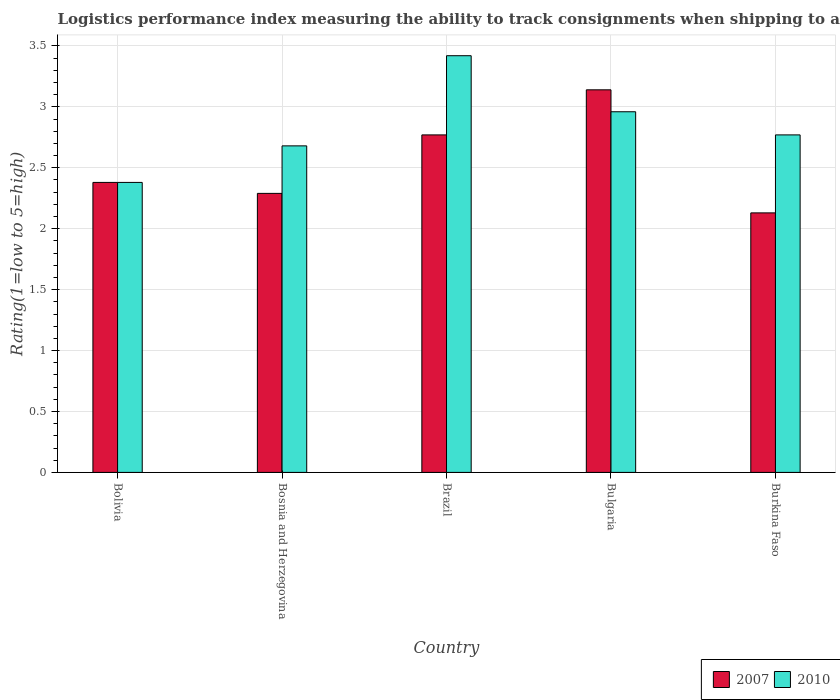How many groups of bars are there?
Your answer should be compact. 5. How many bars are there on the 4th tick from the left?
Your answer should be compact. 2. What is the label of the 4th group of bars from the left?
Provide a succinct answer. Bulgaria. What is the Logistic performance index in 2010 in Bosnia and Herzegovina?
Make the answer very short. 2.68. Across all countries, what is the maximum Logistic performance index in 2007?
Provide a succinct answer. 3.14. Across all countries, what is the minimum Logistic performance index in 2010?
Give a very brief answer. 2.38. In which country was the Logistic performance index in 2007 minimum?
Your response must be concise. Burkina Faso. What is the total Logistic performance index in 2010 in the graph?
Your answer should be very brief. 14.21. What is the difference between the Logistic performance index in 2007 in Bosnia and Herzegovina and that in Brazil?
Your response must be concise. -0.48. What is the difference between the Logistic performance index in 2010 in Burkina Faso and the Logistic performance index in 2007 in Bulgaria?
Ensure brevity in your answer.  -0.37. What is the average Logistic performance index in 2010 per country?
Your answer should be very brief. 2.84. In how many countries, is the Logistic performance index in 2007 greater than 2.7?
Your response must be concise. 2. What is the ratio of the Logistic performance index in 2010 in Bosnia and Herzegovina to that in Burkina Faso?
Give a very brief answer. 0.97. Is the Logistic performance index in 2010 in Bosnia and Herzegovina less than that in Brazil?
Provide a short and direct response. Yes. Is the difference between the Logistic performance index in 2010 in Bolivia and Bosnia and Herzegovina greater than the difference between the Logistic performance index in 2007 in Bolivia and Bosnia and Herzegovina?
Your answer should be very brief. No. What is the difference between the highest and the second highest Logistic performance index in 2007?
Provide a succinct answer. -0.37. What is the difference between the highest and the lowest Logistic performance index in 2010?
Offer a terse response. 1.04. In how many countries, is the Logistic performance index in 2010 greater than the average Logistic performance index in 2010 taken over all countries?
Keep it short and to the point. 2. What does the 2nd bar from the left in Bulgaria represents?
Your answer should be compact. 2010. What does the 1st bar from the right in Bulgaria represents?
Provide a succinct answer. 2010. How many bars are there?
Keep it short and to the point. 10. How many countries are there in the graph?
Keep it short and to the point. 5. Does the graph contain grids?
Ensure brevity in your answer.  Yes. Where does the legend appear in the graph?
Provide a succinct answer. Bottom right. What is the title of the graph?
Make the answer very short. Logistics performance index measuring the ability to track consignments when shipping to a market. What is the label or title of the Y-axis?
Make the answer very short. Rating(1=low to 5=high). What is the Rating(1=low to 5=high) of 2007 in Bolivia?
Offer a terse response. 2.38. What is the Rating(1=low to 5=high) of 2010 in Bolivia?
Give a very brief answer. 2.38. What is the Rating(1=low to 5=high) of 2007 in Bosnia and Herzegovina?
Your answer should be very brief. 2.29. What is the Rating(1=low to 5=high) in 2010 in Bosnia and Herzegovina?
Make the answer very short. 2.68. What is the Rating(1=low to 5=high) of 2007 in Brazil?
Ensure brevity in your answer.  2.77. What is the Rating(1=low to 5=high) in 2010 in Brazil?
Your answer should be very brief. 3.42. What is the Rating(1=low to 5=high) in 2007 in Bulgaria?
Provide a succinct answer. 3.14. What is the Rating(1=low to 5=high) in 2010 in Bulgaria?
Ensure brevity in your answer.  2.96. What is the Rating(1=low to 5=high) of 2007 in Burkina Faso?
Keep it short and to the point. 2.13. What is the Rating(1=low to 5=high) of 2010 in Burkina Faso?
Ensure brevity in your answer.  2.77. Across all countries, what is the maximum Rating(1=low to 5=high) in 2007?
Your response must be concise. 3.14. Across all countries, what is the maximum Rating(1=low to 5=high) in 2010?
Provide a short and direct response. 3.42. Across all countries, what is the minimum Rating(1=low to 5=high) of 2007?
Your response must be concise. 2.13. Across all countries, what is the minimum Rating(1=low to 5=high) in 2010?
Ensure brevity in your answer.  2.38. What is the total Rating(1=low to 5=high) of 2007 in the graph?
Ensure brevity in your answer.  12.71. What is the total Rating(1=low to 5=high) in 2010 in the graph?
Your answer should be compact. 14.21. What is the difference between the Rating(1=low to 5=high) in 2007 in Bolivia and that in Bosnia and Herzegovina?
Provide a short and direct response. 0.09. What is the difference between the Rating(1=low to 5=high) in 2007 in Bolivia and that in Brazil?
Ensure brevity in your answer.  -0.39. What is the difference between the Rating(1=low to 5=high) in 2010 in Bolivia and that in Brazil?
Make the answer very short. -1.04. What is the difference between the Rating(1=low to 5=high) of 2007 in Bolivia and that in Bulgaria?
Make the answer very short. -0.76. What is the difference between the Rating(1=low to 5=high) of 2010 in Bolivia and that in Bulgaria?
Make the answer very short. -0.58. What is the difference between the Rating(1=low to 5=high) of 2010 in Bolivia and that in Burkina Faso?
Your answer should be compact. -0.39. What is the difference between the Rating(1=low to 5=high) in 2007 in Bosnia and Herzegovina and that in Brazil?
Your answer should be compact. -0.48. What is the difference between the Rating(1=low to 5=high) in 2010 in Bosnia and Herzegovina and that in Brazil?
Keep it short and to the point. -0.74. What is the difference between the Rating(1=low to 5=high) in 2007 in Bosnia and Herzegovina and that in Bulgaria?
Keep it short and to the point. -0.85. What is the difference between the Rating(1=low to 5=high) in 2010 in Bosnia and Herzegovina and that in Bulgaria?
Give a very brief answer. -0.28. What is the difference between the Rating(1=low to 5=high) in 2007 in Bosnia and Herzegovina and that in Burkina Faso?
Your response must be concise. 0.16. What is the difference between the Rating(1=low to 5=high) in 2010 in Bosnia and Herzegovina and that in Burkina Faso?
Offer a very short reply. -0.09. What is the difference between the Rating(1=low to 5=high) of 2007 in Brazil and that in Bulgaria?
Your response must be concise. -0.37. What is the difference between the Rating(1=low to 5=high) in 2010 in Brazil and that in Bulgaria?
Provide a succinct answer. 0.46. What is the difference between the Rating(1=low to 5=high) of 2007 in Brazil and that in Burkina Faso?
Your response must be concise. 0.64. What is the difference between the Rating(1=low to 5=high) in 2010 in Brazil and that in Burkina Faso?
Your response must be concise. 0.65. What is the difference between the Rating(1=low to 5=high) in 2007 in Bulgaria and that in Burkina Faso?
Keep it short and to the point. 1.01. What is the difference between the Rating(1=low to 5=high) in 2010 in Bulgaria and that in Burkina Faso?
Keep it short and to the point. 0.19. What is the difference between the Rating(1=low to 5=high) of 2007 in Bolivia and the Rating(1=low to 5=high) of 2010 in Bosnia and Herzegovina?
Offer a terse response. -0.3. What is the difference between the Rating(1=low to 5=high) of 2007 in Bolivia and the Rating(1=low to 5=high) of 2010 in Brazil?
Make the answer very short. -1.04. What is the difference between the Rating(1=low to 5=high) of 2007 in Bolivia and the Rating(1=low to 5=high) of 2010 in Bulgaria?
Ensure brevity in your answer.  -0.58. What is the difference between the Rating(1=low to 5=high) in 2007 in Bolivia and the Rating(1=low to 5=high) in 2010 in Burkina Faso?
Offer a very short reply. -0.39. What is the difference between the Rating(1=low to 5=high) in 2007 in Bosnia and Herzegovina and the Rating(1=low to 5=high) in 2010 in Brazil?
Ensure brevity in your answer.  -1.13. What is the difference between the Rating(1=low to 5=high) of 2007 in Bosnia and Herzegovina and the Rating(1=low to 5=high) of 2010 in Bulgaria?
Give a very brief answer. -0.67. What is the difference between the Rating(1=low to 5=high) in 2007 in Bosnia and Herzegovina and the Rating(1=low to 5=high) in 2010 in Burkina Faso?
Keep it short and to the point. -0.48. What is the difference between the Rating(1=low to 5=high) in 2007 in Brazil and the Rating(1=low to 5=high) in 2010 in Bulgaria?
Ensure brevity in your answer.  -0.19. What is the difference between the Rating(1=low to 5=high) in 2007 in Brazil and the Rating(1=low to 5=high) in 2010 in Burkina Faso?
Your response must be concise. 0. What is the difference between the Rating(1=low to 5=high) of 2007 in Bulgaria and the Rating(1=low to 5=high) of 2010 in Burkina Faso?
Provide a short and direct response. 0.37. What is the average Rating(1=low to 5=high) of 2007 per country?
Your answer should be compact. 2.54. What is the average Rating(1=low to 5=high) of 2010 per country?
Your answer should be compact. 2.84. What is the difference between the Rating(1=low to 5=high) in 2007 and Rating(1=low to 5=high) in 2010 in Bolivia?
Give a very brief answer. 0. What is the difference between the Rating(1=low to 5=high) in 2007 and Rating(1=low to 5=high) in 2010 in Bosnia and Herzegovina?
Ensure brevity in your answer.  -0.39. What is the difference between the Rating(1=low to 5=high) in 2007 and Rating(1=low to 5=high) in 2010 in Brazil?
Offer a terse response. -0.65. What is the difference between the Rating(1=low to 5=high) of 2007 and Rating(1=low to 5=high) of 2010 in Bulgaria?
Offer a very short reply. 0.18. What is the difference between the Rating(1=low to 5=high) in 2007 and Rating(1=low to 5=high) in 2010 in Burkina Faso?
Offer a very short reply. -0.64. What is the ratio of the Rating(1=low to 5=high) of 2007 in Bolivia to that in Bosnia and Herzegovina?
Keep it short and to the point. 1.04. What is the ratio of the Rating(1=low to 5=high) in 2010 in Bolivia to that in Bosnia and Herzegovina?
Ensure brevity in your answer.  0.89. What is the ratio of the Rating(1=low to 5=high) in 2007 in Bolivia to that in Brazil?
Offer a very short reply. 0.86. What is the ratio of the Rating(1=low to 5=high) of 2010 in Bolivia to that in Brazil?
Offer a terse response. 0.7. What is the ratio of the Rating(1=low to 5=high) in 2007 in Bolivia to that in Bulgaria?
Provide a short and direct response. 0.76. What is the ratio of the Rating(1=low to 5=high) of 2010 in Bolivia to that in Bulgaria?
Make the answer very short. 0.8. What is the ratio of the Rating(1=low to 5=high) in 2007 in Bolivia to that in Burkina Faso?
Offer a terse response. 1.12. What is the ratio of the Rating(1=low to 5=high) of 2010 in Bolivia to that in Burkina Faso?
Give a very brief answer. 0.86. What is the ratio of the Rating(1=low to 5=high) of 2007 in Bosnia and Herzegovina to that in Brazil?
Make the answer very short. 0.83. What is the ratio of the Rating(1=low to 5=high) of 2010 in Bosnia and Herzegovina to that in Brazil?
Your answer should be compact. 0.78. What is the ratio of the Rating(1=low to 5=high) of 2007 in Bosnia and Herzegovina to that in Bulgaria?
Your response must be concise. 0.73. What is the ratio of the Rating(1=low to 5=high) of 2010 in Bosnia and Herzegovina to that in Bulgaria?
Offer a very short reply. 0.91. What is the ratio of the Rating(1=low to 5=high) in 2007 in Bosnia and Herzegovina to that in Burkina Faso?
Make the answer very short. 1.08. What is the ratio of the Rating(1=low to 5=high) in 2010 in Bosnia and Herzegovina to that in Burkina Faso?
Give a very brief answer. 0.97. What is the ratio of the Rating(1=low to 5=high) of 2007 in Brazil to that in Bulgaria?
Your answer should be very brief. 0.88. What is the ratio of the Rating(1=low to 5=high) of 2010 in Brazil to that in Bulgaria?
Provide a short and direct response. 1.16. What is the ratio of the Rating(1=low to 5=high) in 2007 in Brazil to that in Burkina Faso?
Make the answer very short. 1.3. What is the ratio of the Rating(1=low to 5=high) in 2010 in Brazil to that in Burkina Faso?
Offer a very short reply. 1.23. What is the ratio of the Rating(1=low to 5=high) of 2007 in Bulgaria to that in Burkina Faso?
Give a very brief answer. 1.47. What is the ratio of the Rating(1=low to 5=high) in 2010 in Bulgaria to that in Burkina Faso?
Make the answer very short. 1.07. What is the difference between the highest and the second highest Rating(1=low to 5=high) in 2007?
Offer a terse response. 0.37. What is the difference between the highest and the second highest Rating(1=low to 5=high) in 2010?
Offer a terse response. 0.46. What is the difference between the highest and the lowest Rating(1=low to 5=high) of 2007?
Your answer should be compact. 1.01. 